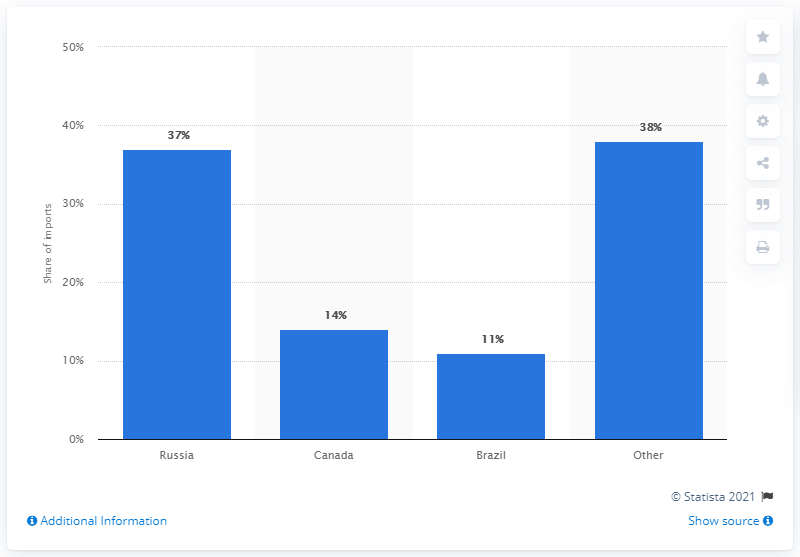Identify some key points in this picture. The primary exporter of silicon to the United States was Russia. According to the given data, Russia accounted for 37% of ferrosilicon imports. 